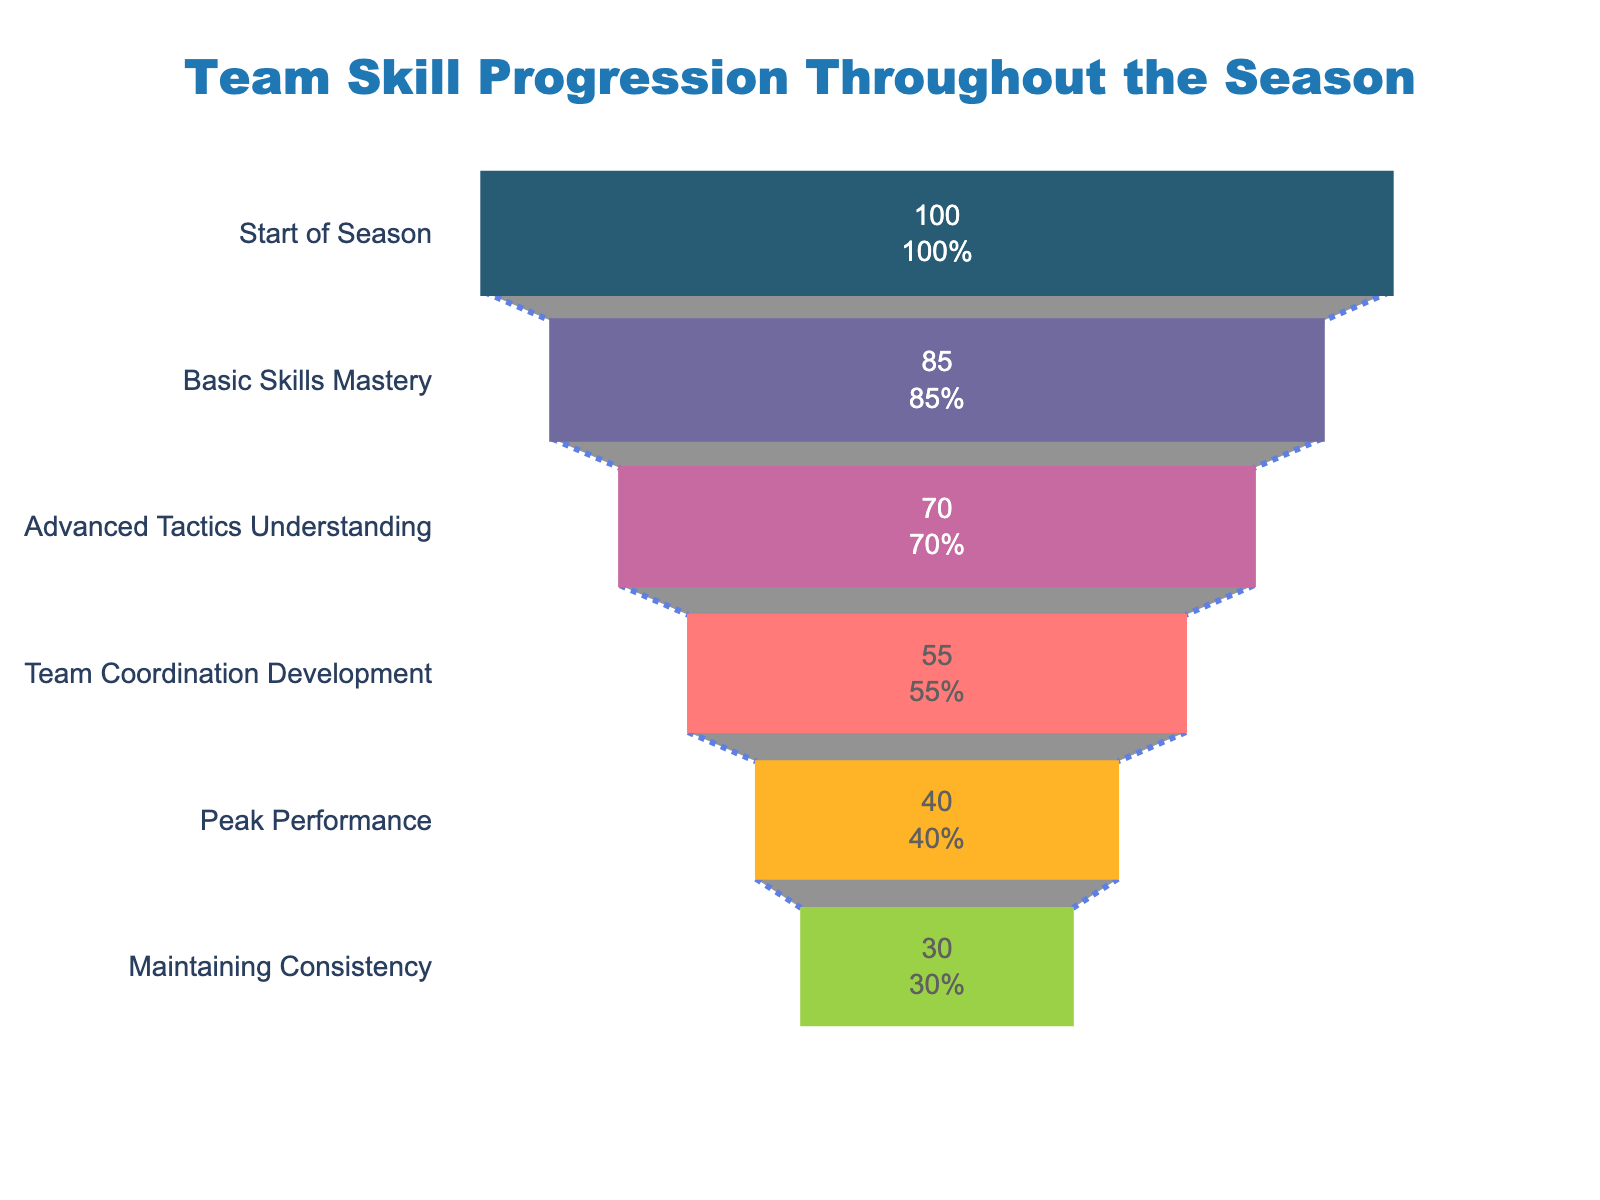What's the title of the figure? The title is visible at the top of the figure. It gives an overview of the data being represented.
Answer: Team Skill Progression Throughout the Season How many stages are shown in the funnel chart? Count the number of unique stages listed on the y-axis of the funnel chart. Each stage represents a specific point in the season progression.
Answer: 6 Which stage has the most players improving? Look for the largest section in terms of width in the funnel chart since a larger width represents more players.
Answer: Start of Season What percentage of players maintain consistency throughout the season compared to the start? Find the number of players maintaining consistency and divide it by the number of players at the start of the season, then multiply by 100 to get the percentage.
Answer: 30% How many players improved from mastering basic skills to understanding advanced tactics? Subtract the number of players at 'Advanced Tactics Understanding' from the number at 'Basic Skills Mastery'.
Answer: 15 players What is the difference in the number of players between 'Peak Performance' and 'Team Coordination Development'? Subtract the number of players improving in 'Peak Performance' from those improving in 'Team Coordination Development'.
Answer: 15 players In which stage do the fewest players improve? Identify the smallest section in the funnel chart by its width, reflecting the fewest players.
Answer: Maintaining Consistency How many players progressed to at least understanding advanced tactics? Sum the number of players who improved at each stage from the start of the season up to and including 'Advanced Tactics Understanding'.
Answer: 255 players Which stage shows a drop of 15 players from the previous stage? Identify the stages where the difference between the number of players at the current and previous stage equals 15.
Answer: Basic Skills Mastery to Advanced Tactics Understanding What is unique about the line style connecting the stages? The standard line used in funnel charts typically connects the stages; here, the style can include color, dash, and width details, although we see the result not the code.
Answer: Royal blue, dash-dot style 